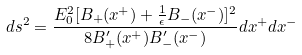<formula> <loc_0><loc_0><loc_500><loc_500>d s ^ { 2 } = \frac { E ^ { 2 } _ { 0 } [ B _ { + } ( x ^ { + } ) + \frac { 1 } { \epsilon } B _ { - } ( x ^ { - } ) ] ^ { 2 } } { 8 B ^ { \prime } _ { + } ( x ^ { + } ) B ^ { \prime } _ { - } ( x ^ { - } ) } d x ^ { + } d x ^ { - }</formula> 